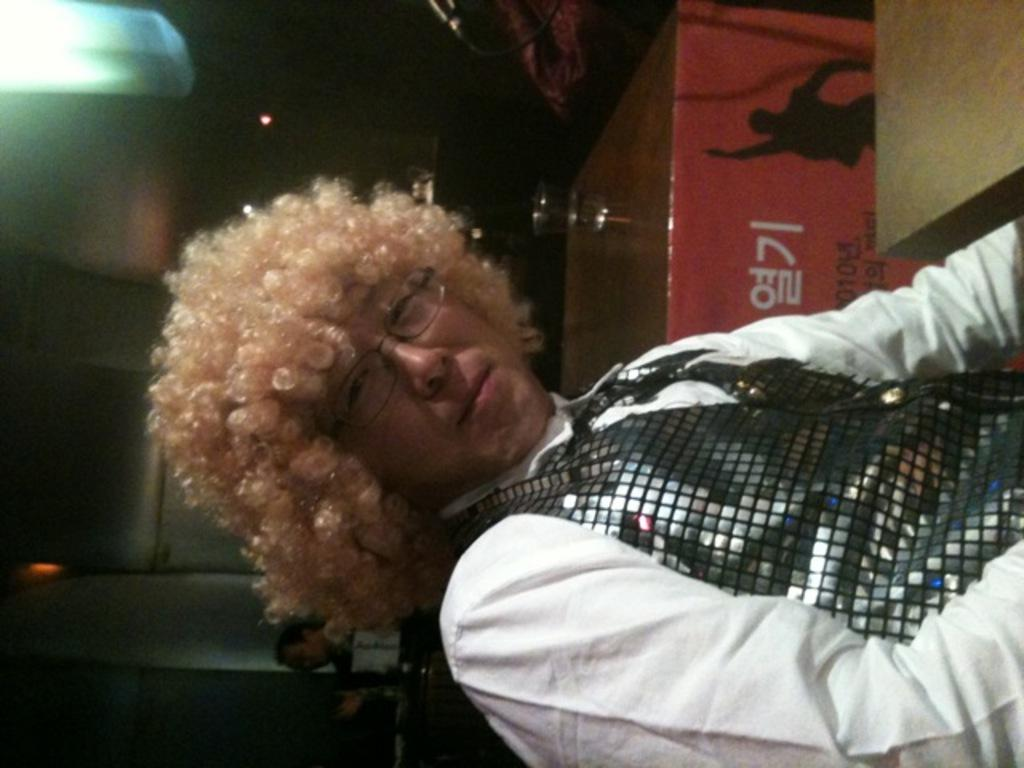Who is present in the image? There is a man in the image. What is unique about the man's hair? The man has gold curly hair. What can be seen at the top of the image? There is a light at the top of the image. What is in the background of the image? There is a table in the background of the image. What is on the table? There is a glass with water on the table. What type of vessel is being used to transport the fire in the image? There is no vessel or fire present in the image. 